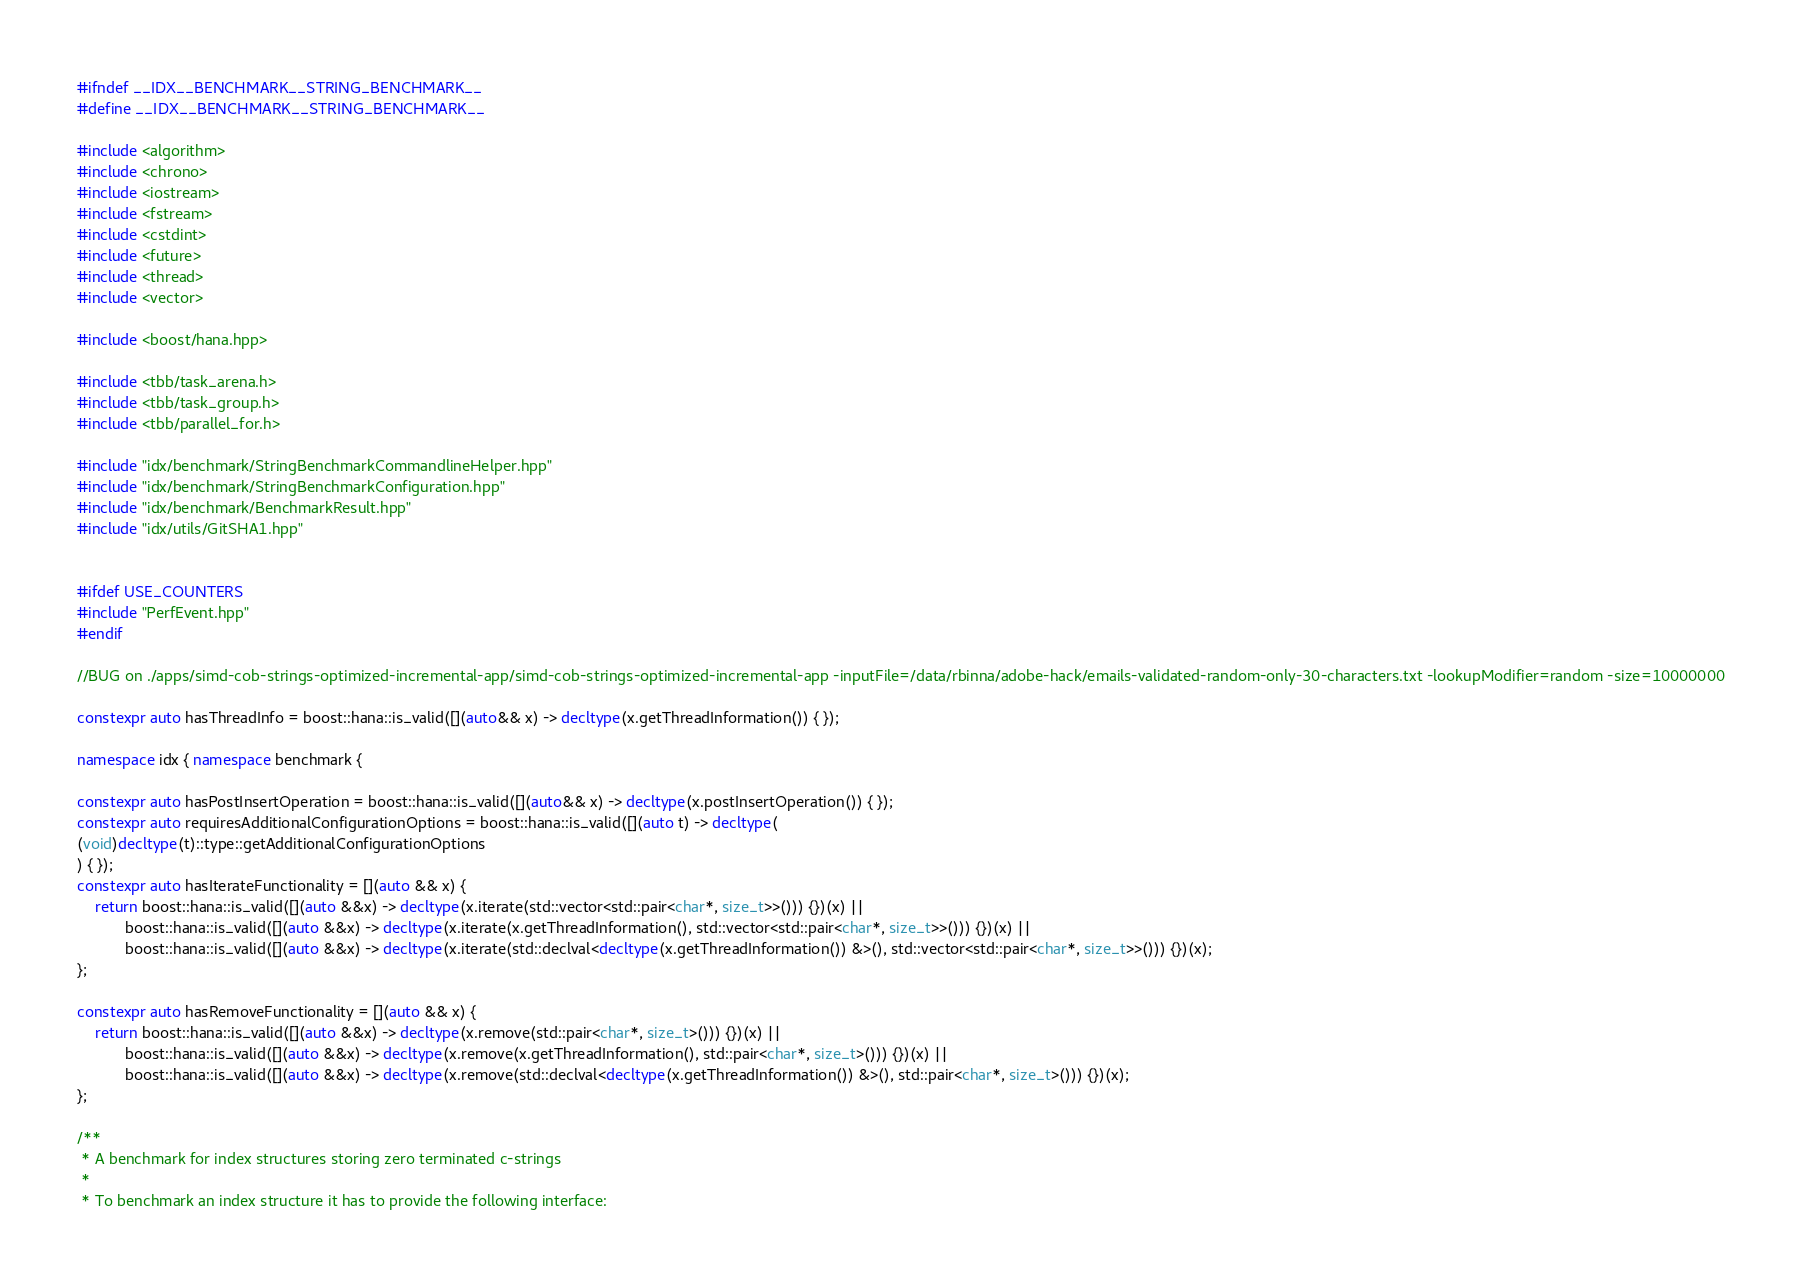Convert code to text. <code><loc_0><loc_0><loc_500><loc_500><_C++_>#ifndef __IDX__BENCHMARK__STRING_BENCHMARK__
#define __IDX__BENCHMARK__STRING_BENCHMARK__

#include <algorithm>
#include <chrono>
#include <iostream>
#include <fstream>
#include <cstdint>
#include <future>
#include <thread>
#include <vector>

#include <boost/hana.hpp>

#include <tbb/task_arena.h>
#include <tbb/task_group.h>
#include <tbb/parallel_for.h>

#include "idx/benchmark/StringBenchmarkCommandlineHelper.hpp"
#include "idx/benchmark/StringBenchmarkConfiguration.hpp"
#include "idx/benchmark/BenchmarkResult.hpp"
#include "idx/utils/GitSHA1.hpp"


#ifdef USE_COUNTERS
#include "PerfEvent.hpp"
#endif

//BUG on ./apps/simd-cob-strings-optimized-incremental-app/simd-cob-strings-optimized-incremental-app -inputFile=/data/rbinna/adobe-hack/emails-validated-random-only-30-characters.txt -lookupModifier=random -size=10000000

constexpr auto hasThreadInfo = boost::hana::is_valid([](auto&& x) -> decltype(x.getThreadInformation()) { });

namespace idx { namespace benchmark {

constexpr auto hasPostInsertOperation = boost::hana::is_valid([](auto&& x) -> decltype(x.postInsertOperation()) { });
constexpr auto requiresAdditionalConfigurationOptions = boost::hana::is_valid([](auto t) -> decltype(
(void)decltype(t)::type::getAdditionalConfigurationOptions
) { });
constexpr auto hasIterateFunctionality = [](auto && x) {
	return boost::hana::is_valid([](auto &&x) -> decltype(x.iterate(std::vector<std::pair<char*, size_t>>())) {})(x) ||
		   boost::hana::is_valid([](auto &&x) -> decltype(x.iterate(x.getThreadInformation(), std::vector<std::pair<char*, size_t>>())) {})(x) ||
		   boost::hana::is_valid([](auto &&x) -> decltype(x.iterate(std::declval<decltype(x.getThreadInformation()) &>(), std::vector<std::pair<char*, size_t>>())) {})(x);
};

constexpr auto hasRemoveFunctionality = [](auto && x) {
	return boost::hana::is_valid([](auto &&x) -> decltype(x.remove(std::pair<char*, size_t>())) {})(x) ||
		   boost::hana::is_valid([](auto &&x) -> decltype(x.remove(x.getThreadInformation(), std::pair<char*, size_t>())) {})(x) ||
		   boost::hana::is_valid([](auto &&x) -> decltype(x.remove(std::declval<decltype(x.getThreadInformation()) &>(), std::pair<char*, size_t>())) {})(x);
};

/**
 * A benchmark for index structures storing zero terminated c-strings
 *
 * To benchmark an index structure it has to provide the following interface:</code> 